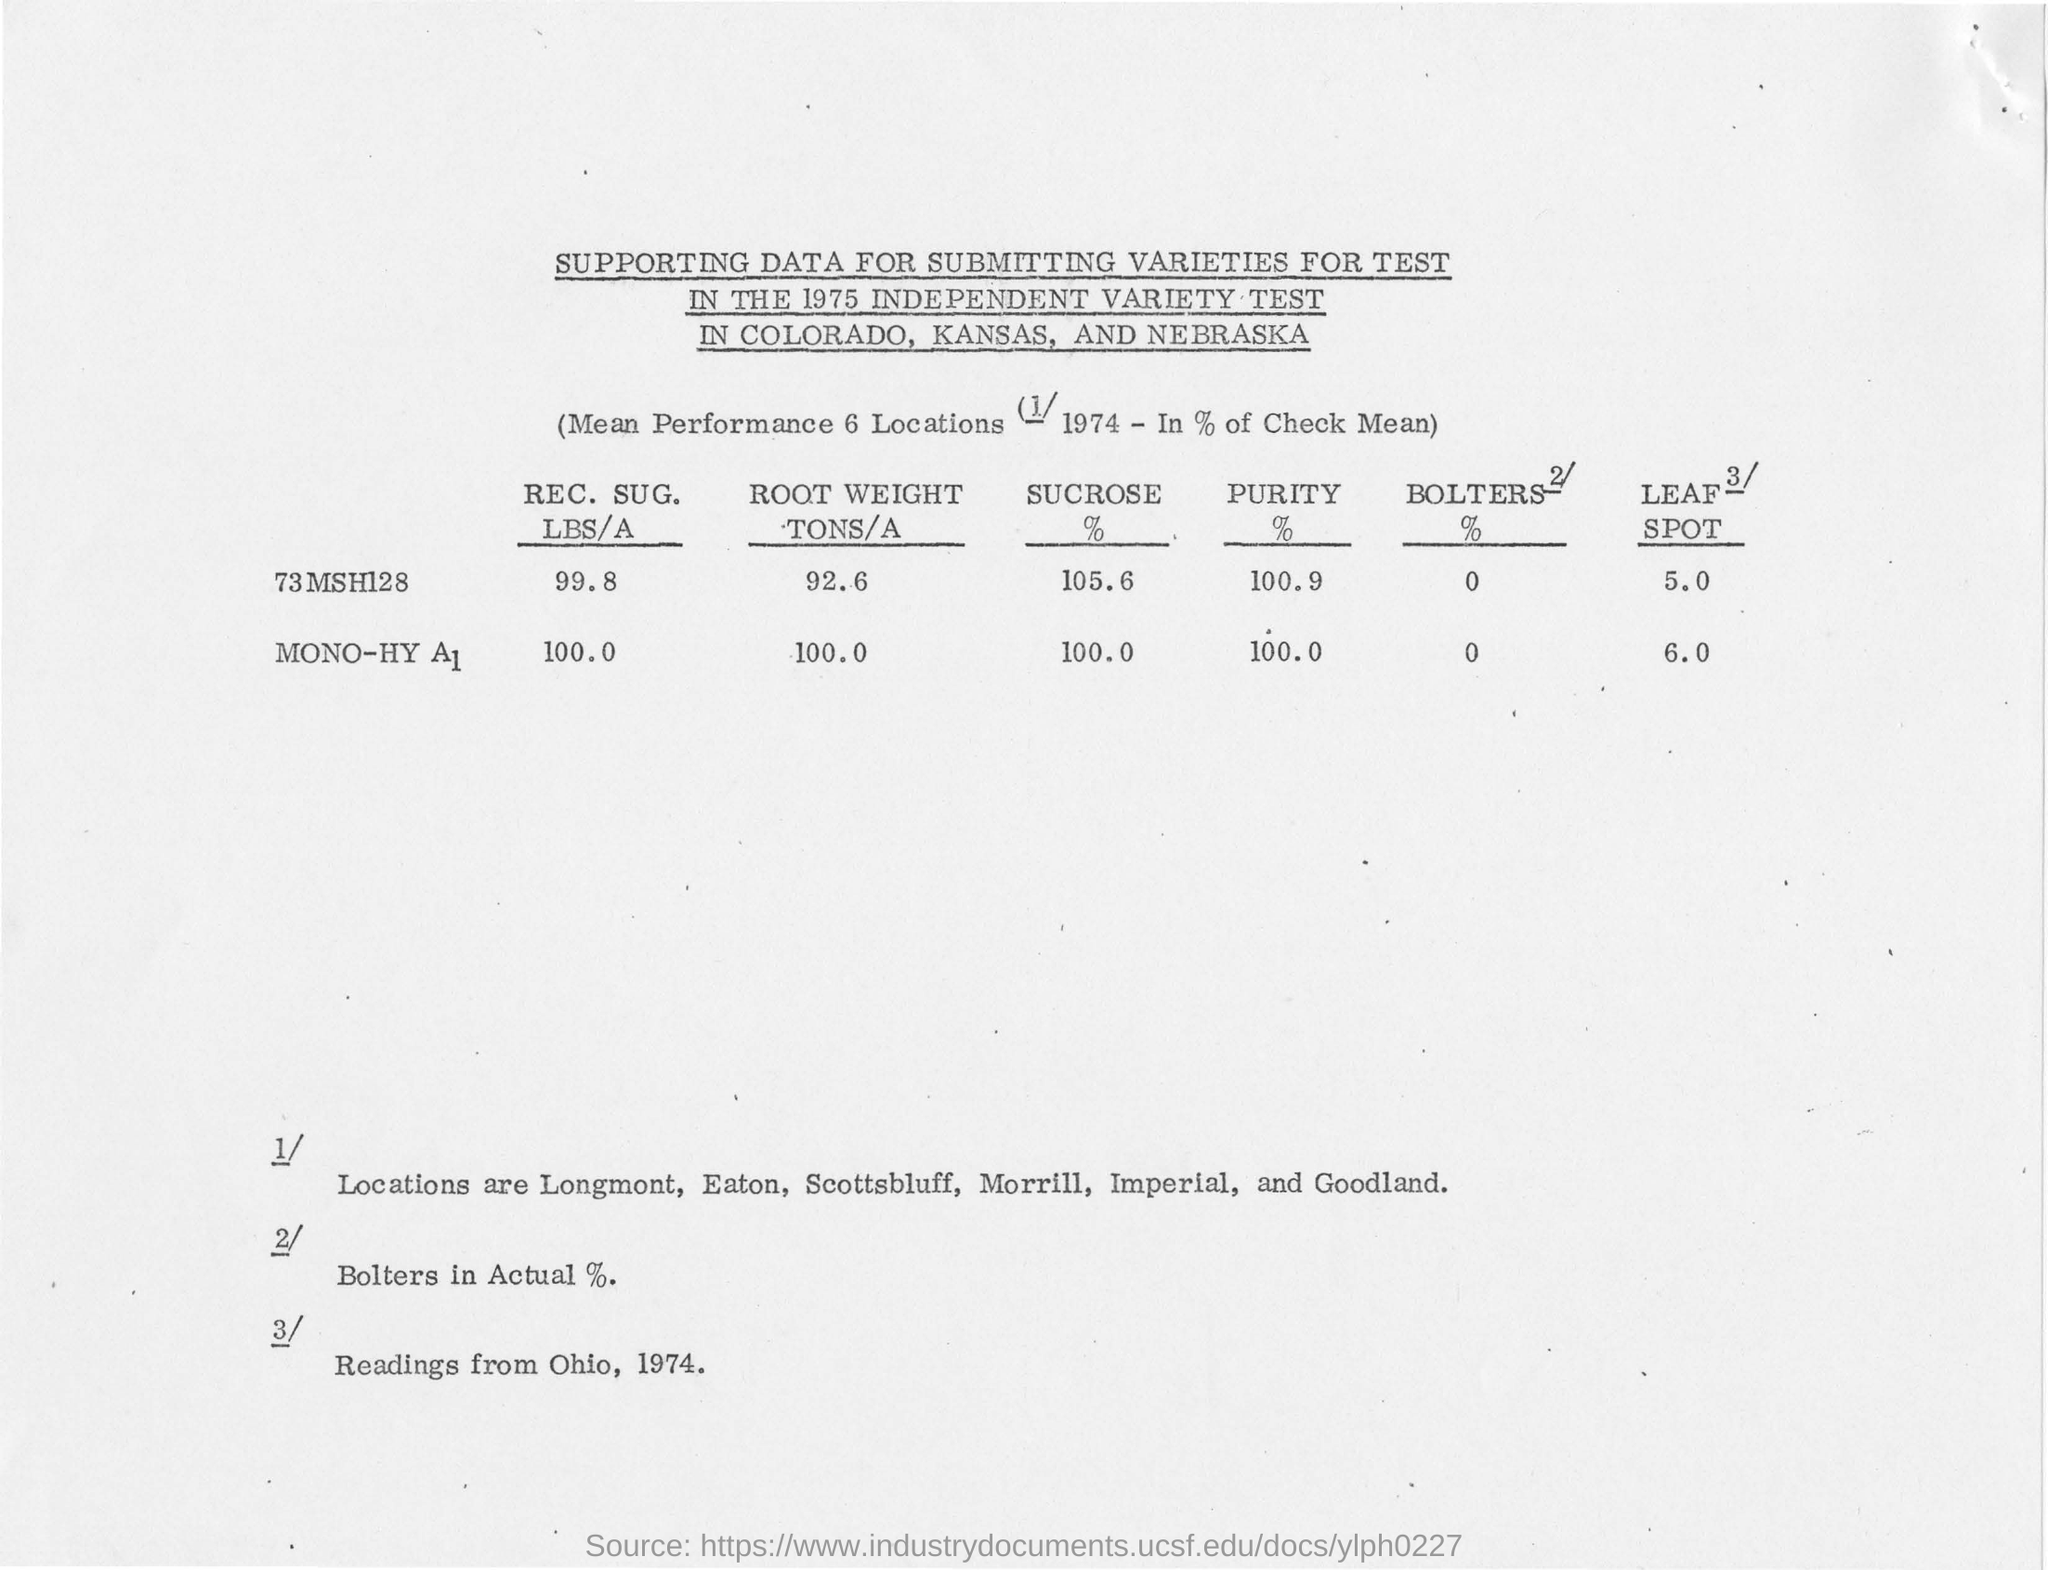Draw attention to some important aspects in this diagram. The sugar content of 73 MSH128 is the highest among the values listed in the table. The root weight of '73 MSH128' in tons/a is 92.6. The independent variety test mentioned in the title of the document is from 1975. 